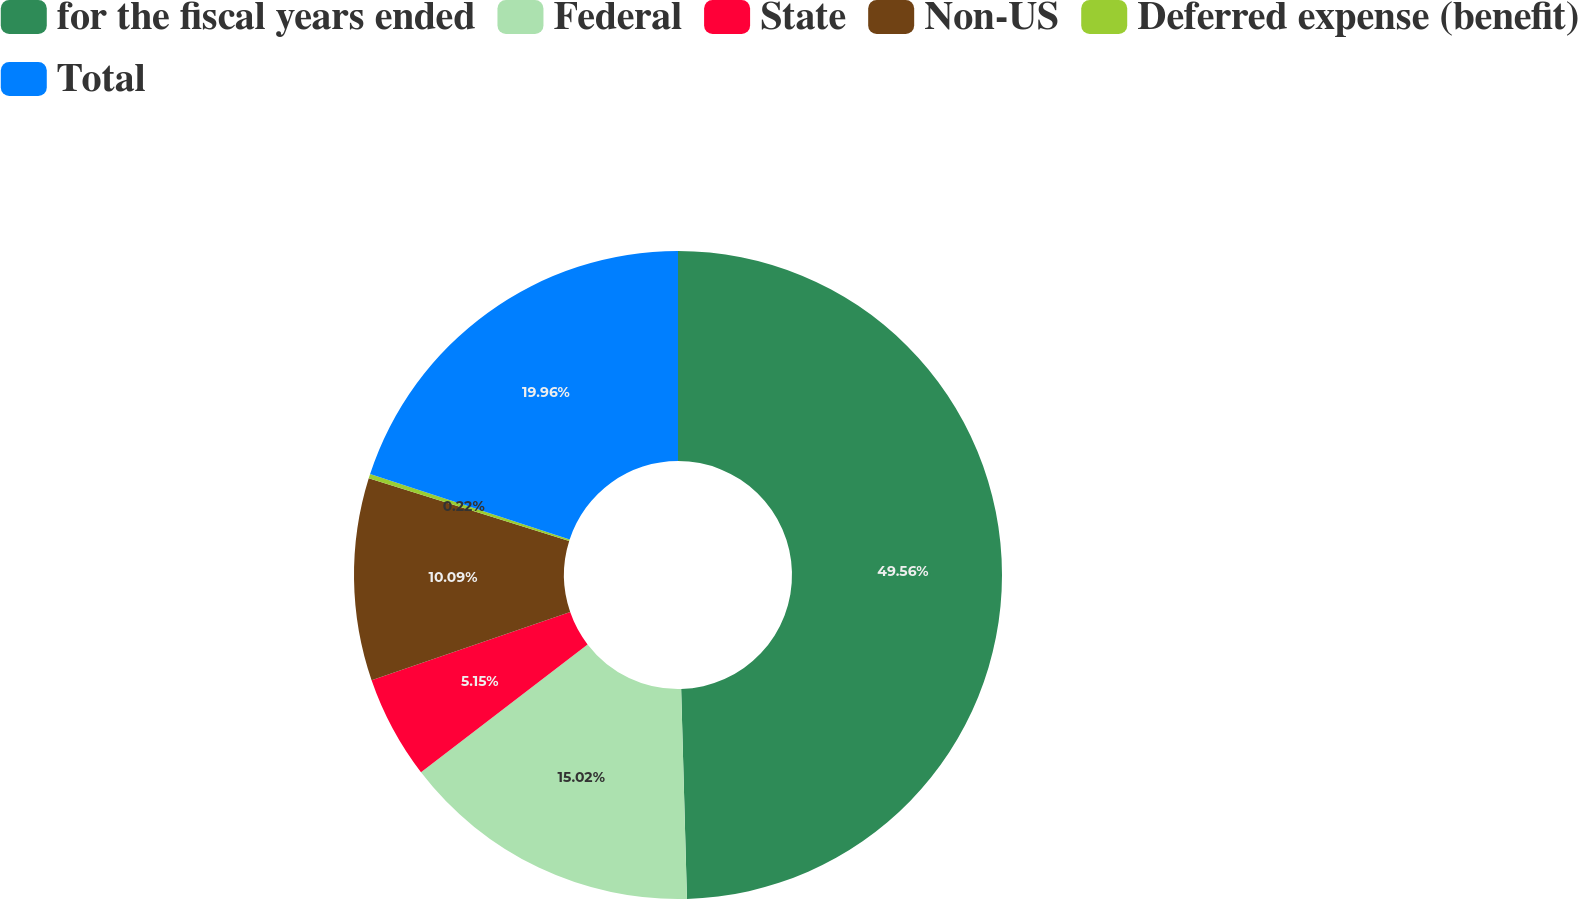Convert chart. <chart><loc_0><loc_0><loc_500><loc_500><pie_chart><fcel>for the fiscal years ended<fcel>Federal<fcel>State<fcel>Non-US<fcel>Deferred expense (benefit)<fcel>Total<nl><fcel>49.56%<fcel>15.02%<fcel>5.15%<fcel>10.09%<fcel>0.22%<fcel>19.96%<nl></chart> 